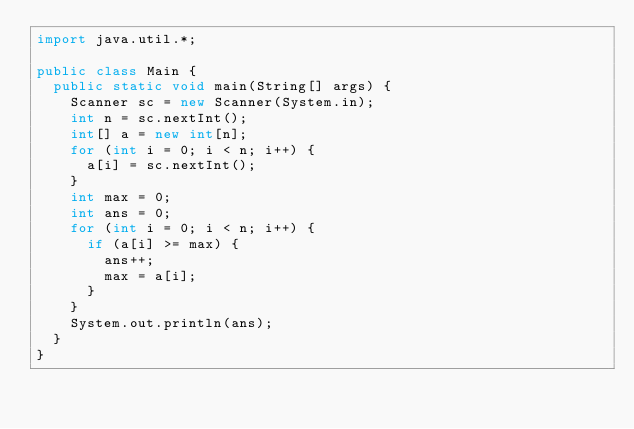<code> <loc_0><loc_0><loc_500><loc_500><_Java_>import java.util.*;

public class Main {
	public static void main(String[] args) {
		Scanner sc = new Scanner(System.in);
		int n = sc.nextInt();
		int[] a = new int[n];
		for (int i = 0; i < n; i++) {
			a[i] = sc.nextInt();
		}
		int max = 0;
		int ans = 0;
		for (int i = 0; i < n; i++) {
			if (a[i] >= max) {
				ans++;
				max = a[i];
			}
		}
		System.out.println(ans);
	}
}</code> 